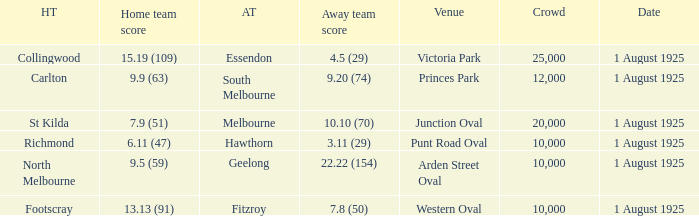Of matches that had a home team score of 13.13 (91), which one had the largest crowd? 10000.0. 